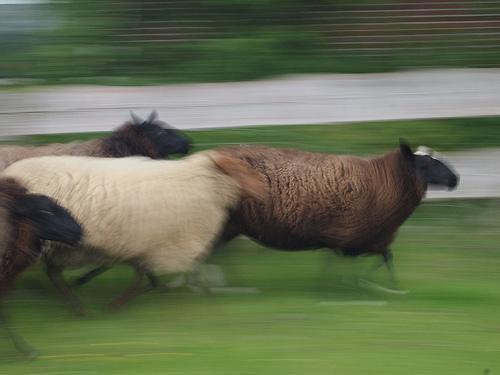How many sheep are white?
Give a very brief answer. 1. 